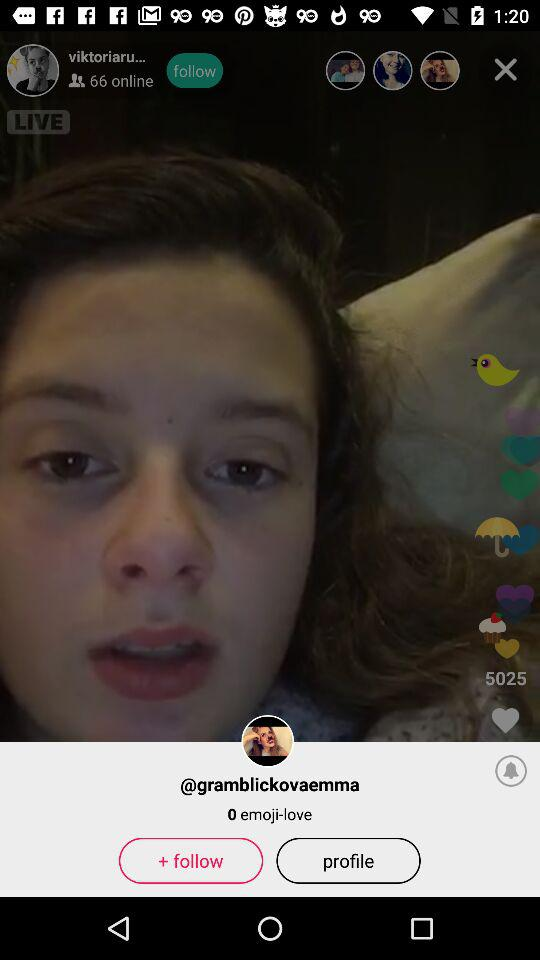How many people are online? There are 66 people online. 